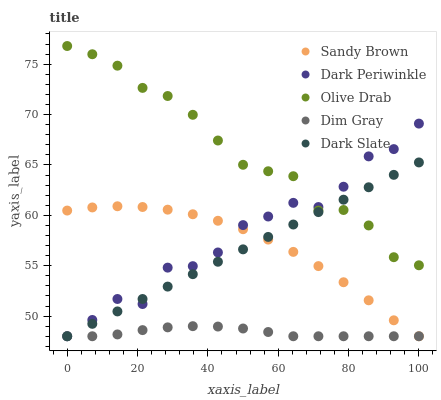Does Dim Gray have the minimum area under the curve?
Answer yes or no. Yes. Does Olive Drab have the maximum area under the curve?
Answer yes or no. Yes. Does Sandy Brown have the minimum area under the curve?
Answer yes or no. No. Does Sandy Brown have the maximum area under the curve?
Answer yes or no. No. Is Dark Slate the smoothest?
Answer yes or no. Yes. Is Dark Periwinkle the roughest?
Answer yes or no. Yes. Is Dim Gray the smoothest?
Answer yes or no. No. Is Dim Gray the roughest?
Answer yes or no. No. Does Dark Slate have the lowest value?
Answer yes or no. Yes. Does Olive Drab have the lowest value?
Answer yes or no. No. Does Olive Drab have the highest value?
Answer yes or no. Yes. Does Sandy Brown have the highest value?
Answer yes or no. No. Is Sandy Brown less than Olive Drab?
Answer yes or no. Yes. Is Olive Drab greater than Dim Gray?
Answer yes or no. Yes. Does Sandy Brown intersect Dark Slate?
Answer yes or no. Yes. Is Sandy Brown less than Dark Slate?
Answer yes or no. No. Is Sandy Brown greater than Dark Slate?
Answer yes or no. No. Does Sandy Brown intersect Olive Drab?
Answer yes or no. No. 